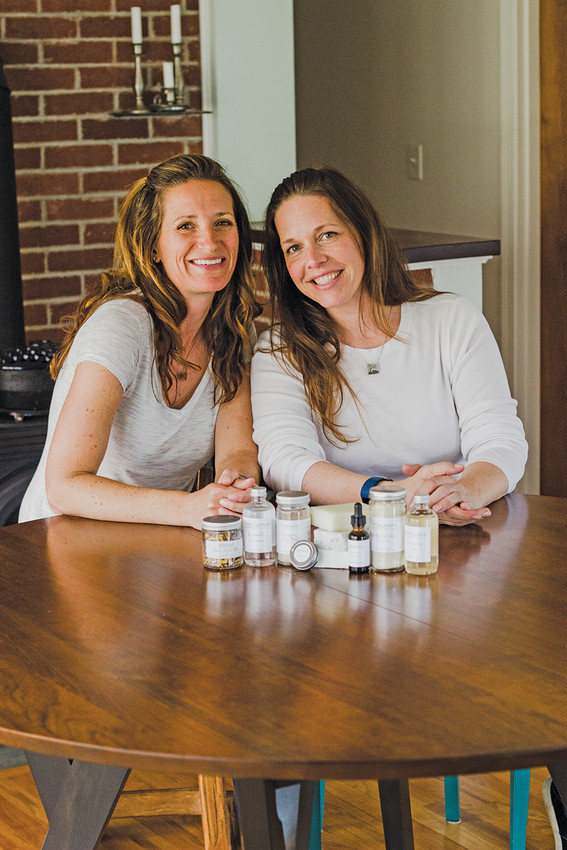What could be the relationship between the two individuals, and how might that play a role in the context of the image? The relationship between the two individuals could be that of siblings, close friends, or possibly business partners. Their similar physical features and the ease with which they appear to interact suggests a close and familiar bond. This relationship plays a significant role in the context of the image, as it suggests a level of trust and collaboration. If the setting involves presenting products, such as skincare items displayed on the table, their camaraderie could indicate a joint venture or a shared passion project. Their positive interaction is likely beneficial in a business context, fostering an atmosphere of reliability and mutual enthusiasm, which can be appealing to potential customers or clients. 